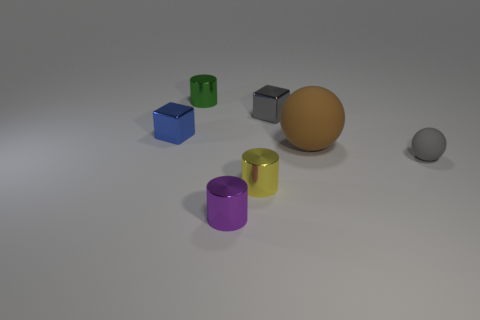There is a cube that is to the right of the small yellow cylinder; is its size the same as the cylinder that is to the right of the tiny purple thing?
Keep it short and to the point. Yes. Is the big brown thing the same shape as the gray metallic object?
Provide a short and direct response. No. How many things are either balls that are on the left side of the tiny rubber thing or small brown matte objects?
Offer a terse response. 1. Are there any big purple matte objects of the same shape as the large brown object?
Provide a short and direct response. No. Are there an equal number of tiny purple things that are right of the small gray sphere and big cyan cubes?
Provide a succinct answer. Yes. What is the shape of the tiny thing that is the same color as the small sphere?
Provide a succinct answer. Cube. How many purple cylinders have the same size as the blue shiny thing?
Make the answer very short. 1. There is a blue thing; what number of tiny purple metallic cylinders are in front of it?
Your answer should be very brief. 1. What is the material of the tiny thing right of the brown ball in front of the blue block?
Give a very brief answer. Rubber. Are there any shiny objects of the same color as the tiny matte sphere?
Offer a terse response. Yes. 